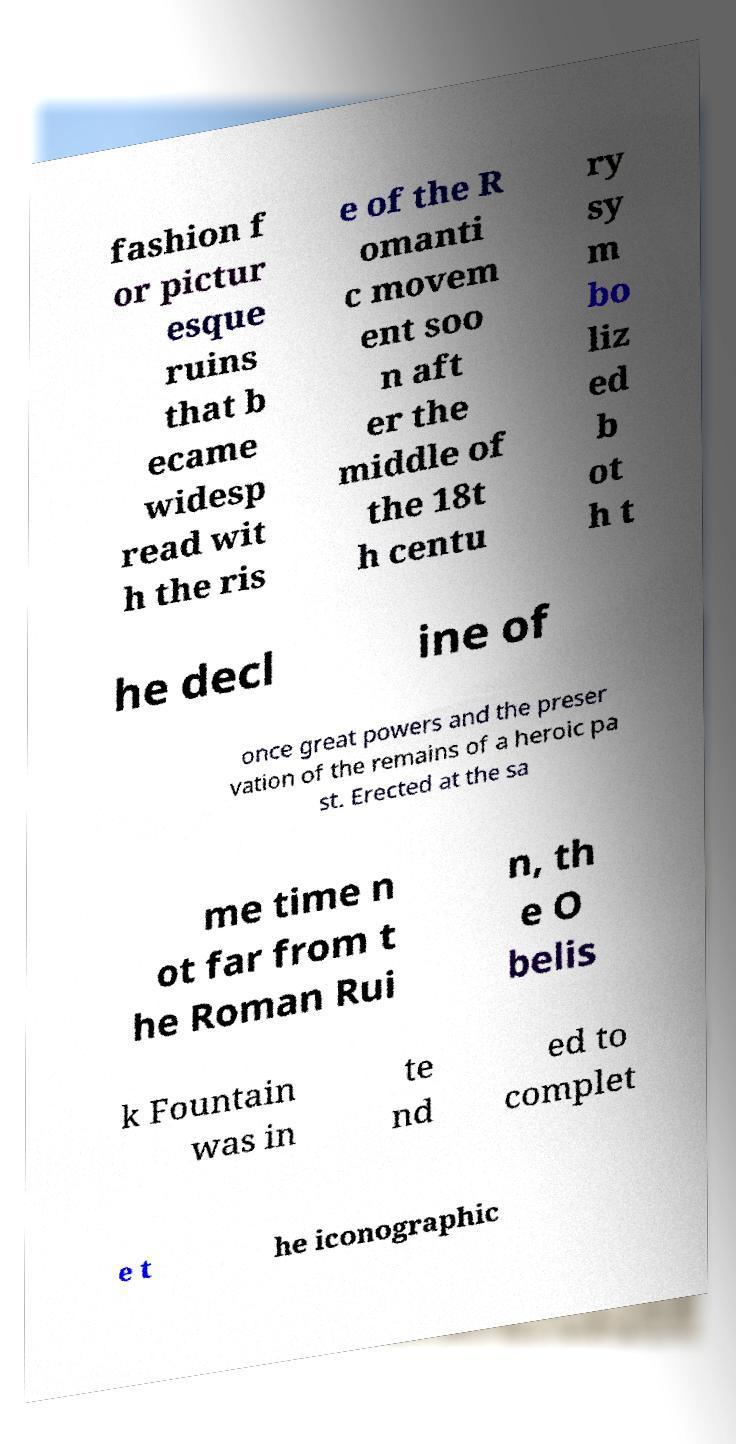Can you accurately transcribe the text from the provided image for me? fashion f or pictur esque ruins that b ecame widesp read wit h the ris e of the R omanti c movem ent soo n aft er the middle of the 18t h centu ry sy m bo liz ed b ot h t he decl ine of once great powers and the preser vation of the remains of a heroic pa st. Erected at the sa me time n ot far from t he Roman Rui n, th e O belis k Fountain was in te nd ed to complet e t he iconographic 